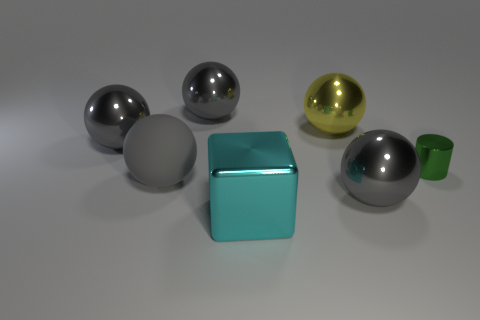How many gray spheres must be subtracted to get 2 gray spheres? 2 Subtract all yellow blocks. How many gray balls are left? 4 Subtract all yellow spheres. How many spheres are left? 4 Subtract all yellow spheres. How many spheres are left? 4 Subtract all green balls. Subtract all blue cubes. How many balls are left? 5 Add 3 shiny cylinders. How many objects exist? 10 Subtract all cylinders. How many objects are left? 6 Add 2 spheres. How many spheres are left? 7 Add 5 big cyan metal blocks. How many big cyan metal blocks exist? 6 Subtract 0 purple spheres. How many objects are left? 7 